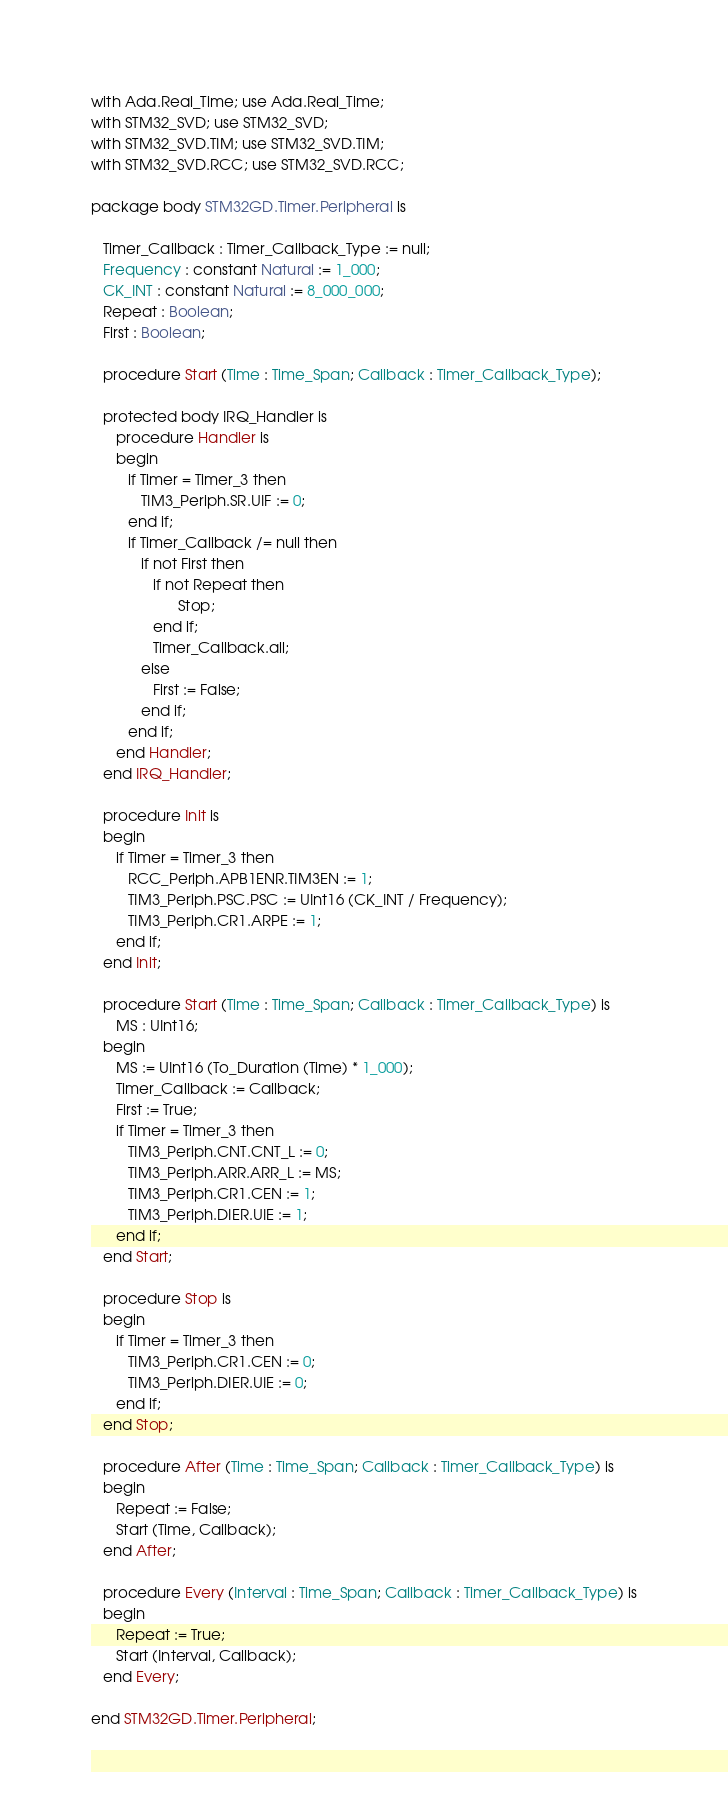<code> <loc_0><loc_0><loc_500><loc_500><_Ada_>with Ada.Real_Time; use Ada.Real_Time;
with STM32_SVD; use STM32_SVD;
with STM32_SVD.TIM; use STM32_SVD.TIM;
with STM32_SVD.RCC; use STM32_SVD.RCC;

package body STM32GD.Timer.Peripheral is

   Timer_Callback : Timer_Callback_Type := null;
   Frequency : constant Natural := 1_000;
   CK_INT : constant Natural := 8_000_000;
   Repeat : Boolean;
   First : Boolean;

   procedure Start (Time : Time_Span; Callback : Timer_Callback_Type);

   protected body IRQ_Handler is
      procedure Handler is
      begin
         if Timer = Timer_3 then
            TIM3_Periph.SR.UIF := 0;
         end if;
         if Timer_Callback /= null then
            if not First then
               if not Repeat then
                     Stop;
               end if;
               Timer_Callback.all;
            else
               First := False;
            end if;
         end if;
      end Handler;
   end IRQ_Handler;

   procedure Init is
   begin
      if Timer = Timer_3 then
         RCC_Periph.APB1ENR.TIM3EN := 1;
         TIM3_Periph.PSC.PSC := UInt16 (CK_INT / Frequency);
         TIM3_Periph.CR1.ARPE := 1;
      end if;
   end Init;

   procedure Start (Time : Time_Span; Callback : Timer_Callback_Type) is
      MS : UInt16;
   begin
      MS := UInt16 (To_Duration (Time) * 1_000);
      Timer_Callback := Callback;
      First := True;
      if Timer = Timer_3 then
         TIM3_Periph.CNT.CNT_L := 0;
         TIM3_Periph.ARR.ARR_L := MS;
         TIM3_Periph.CR1.CEN := 1;
         TIM3_Periph.DIER.UIE := 1;
      end if;
   end Start;

   procedure Stop is
   begin
      if Timer = Timer_3 then
         TIM3_Periph.CR1.CEN := 0;
         TIM3_Periph.DIER.UIE := 0;
      end if;
   end Stop;

   procedure After (Time : Time_Span; Callback : Timer_Callback_Type) is
   begin
      Repeat := False;
      Start (Time, Callback);
   end After;

   procedure Every (Interval : Time_Span; Callback : Timer_Callback_Type) is
   begin
      Repeat := True;
      Start (Interval, Callback);
   end Every;

end STM32GD.Timer.Peripheral;
</code> 